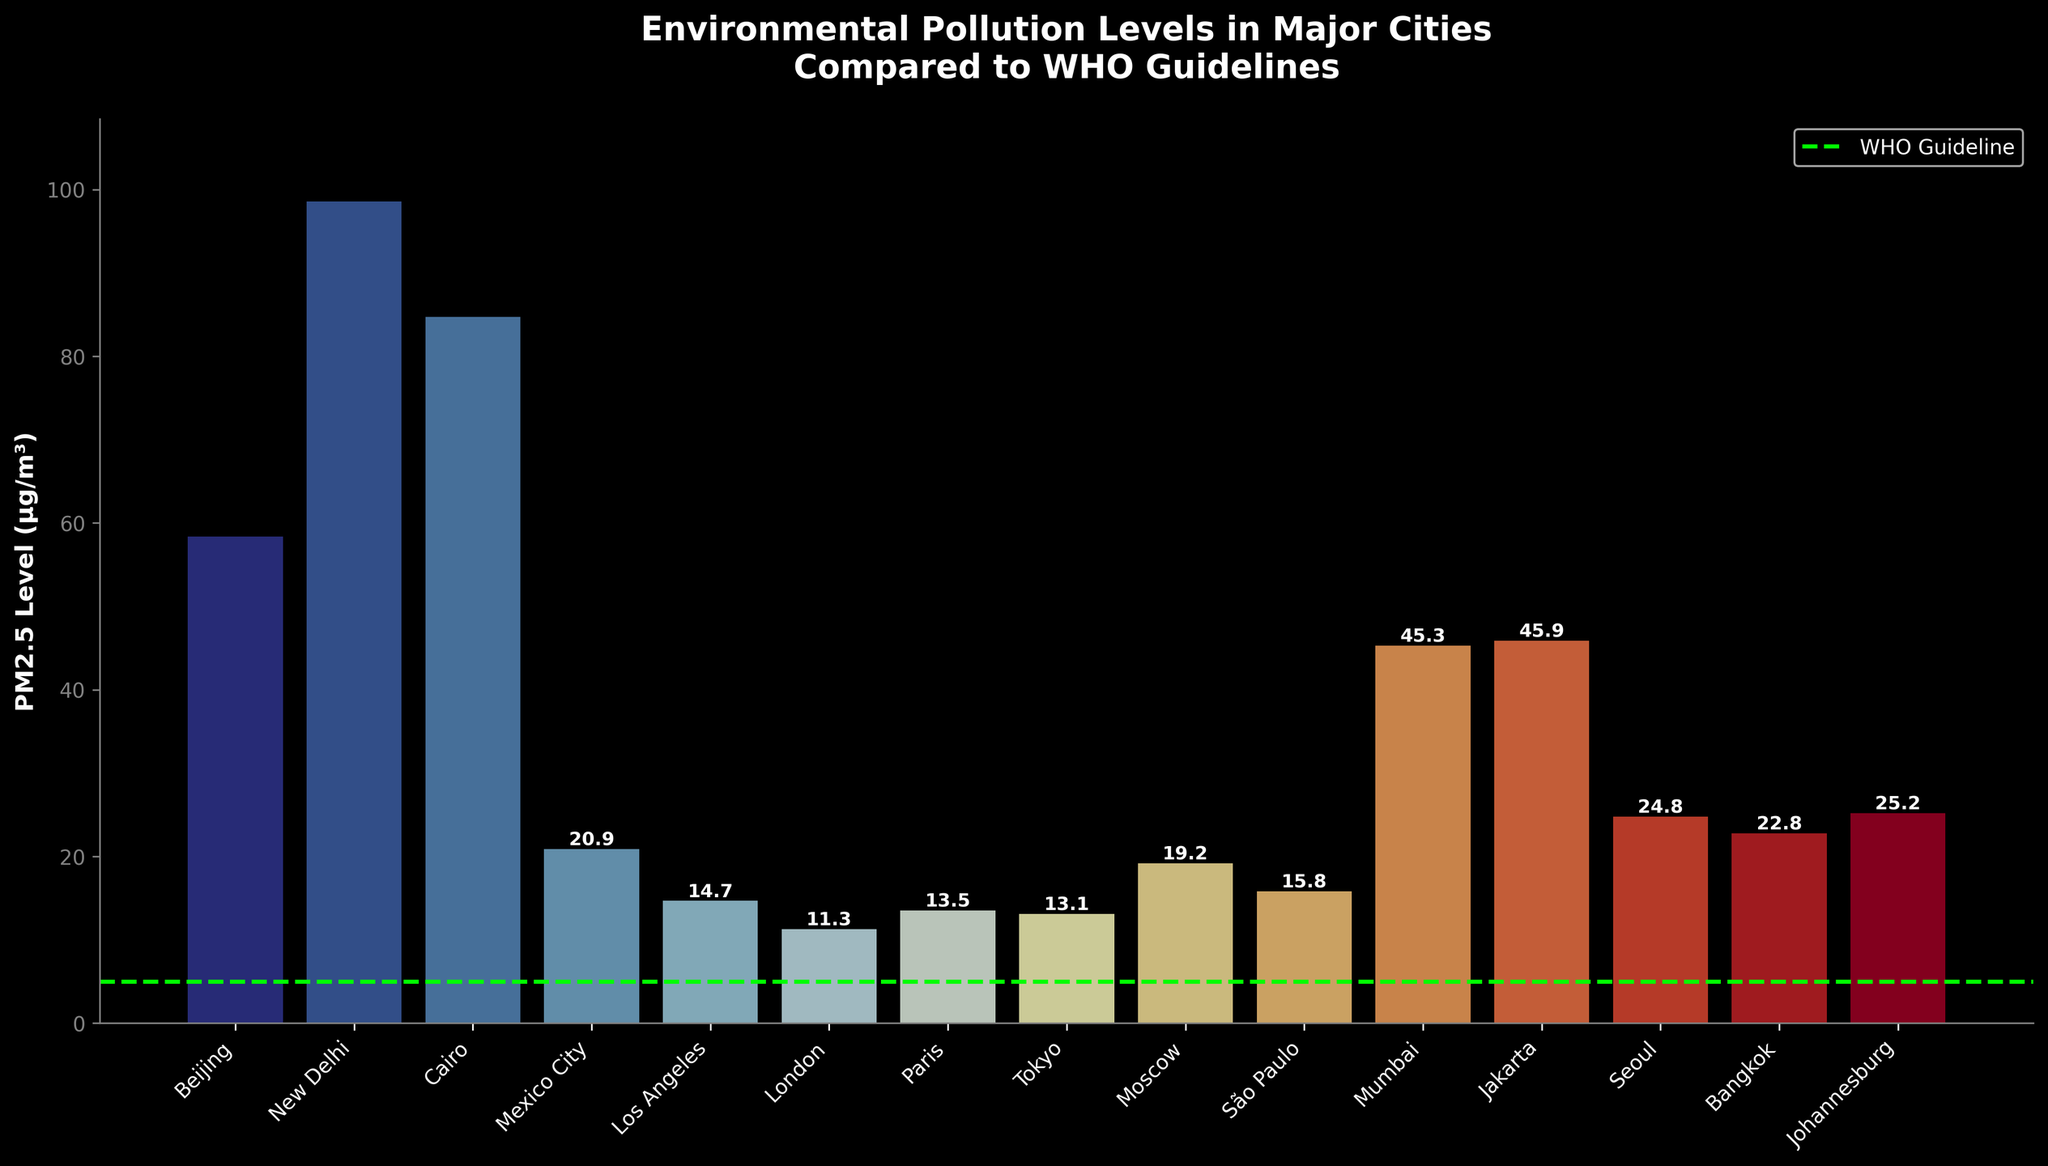Which city has the highest PM2.5 level? The highest PM2.5 level is the tallest bar in the bar chart. Since New Delhi's bar is the highest, it indicates that New Delhi has the highest PM2.5 level.
Answer: New Delhi Which city has the lowest PM2.5 level? The lowest PM2.5 level is indicated by the shortest bar in the bar chart. London has the shortest bar, meaning it has the lowest PM2.5 level among the cities.
Answer: London How many cities have PM2.5 levels above 50 μg/m³? To find this, count the number of bars that reach higher than the 50 μg/m³ mark. There are three bars: Beijing, New Delhi, and Cairo.
Answer: 3 What is the average PM2.5 level of cities with PM2.5 levels below 20 μg/m³? First, identify cities with PM2.5 levels below 20 μg/m³ (Los Angeles, London, Paris, Tokyo). Add their values (14.7 + 11.3 + 13.5 + 13.1 = 52.6), then divide by the number of cities (4). The average is 52.6 / 4 = 13.15 μg/m³.
Answer: 13.15 μg/m³ Which cities have PM2.5 levels less than double the WHO guideline? Double the WHO guideline is 10 μg/m³ (2*5). Find cities with PM2.5 levels below this threshold: None of the cities fit this criterion.
Answer: None Compare the PM2.5 levels of Cairo and São Paulo. Which city has a higher level and by how much? Cairo's PM2.5 level is 84.7 μg/m³, and São Paulo's level is 15.8 μg/m³. The difference is 84.7 - 15.8 = 68.9 μg/m³. Cairo has a higher PM2.5 level by 68.9 μg/m³.
Answer: Cairo, 68.9 μg/m³ What are the PM2.5 levels for cities in Asia, and how do these compare to the WHO guideline? The Asian cities listed are Beijing (58.4 μg/m³), New Delhi (98.6 μg/m³), Tokyo (13.1 μg/m³), Mumbai (45.3 μg/m³), Jakarta (45.9 μg/m³), and Seoul (24.8 μg/m³). All these levels are significantly higher than the WHO guideline of 5 μg/m³.
Answer: All higher than WHO guideline How much higher is the PM2.5 level in Johannesburg compared to Los Angeles? Johannesburg's PM2.5 level is 25.2 μg/m³, while Los Angeles' level is 14.7 μg/m³. The difference is 25.2 - 14.7 = 10.5 μg/m³.
Answer: 10.5 μg/m³ 